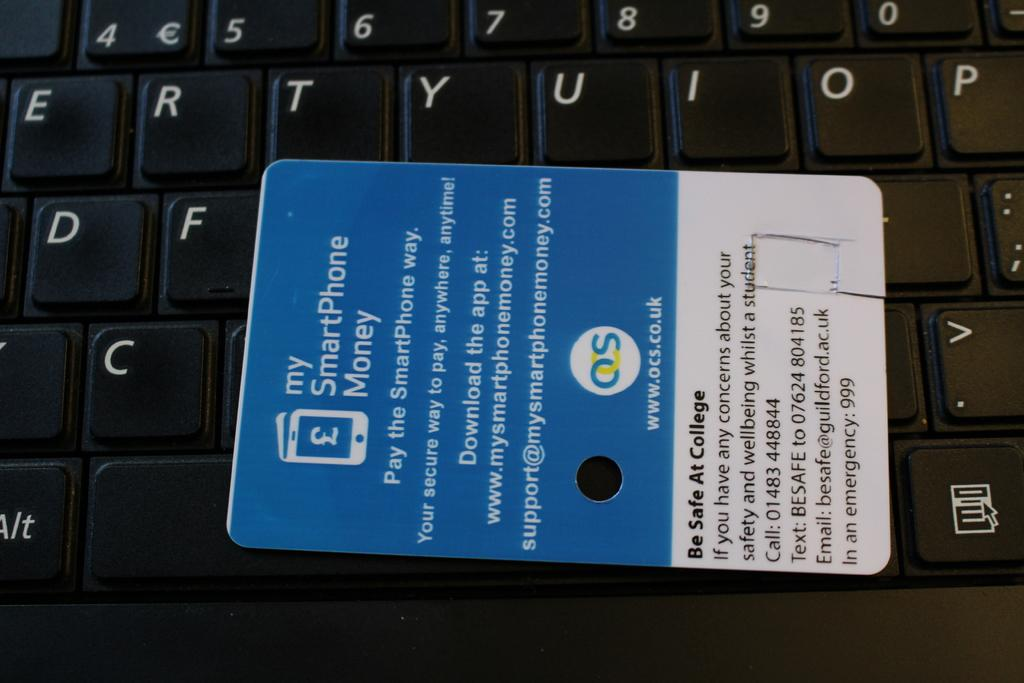Provide a one-sentence caption for the provided image. An advertising card for My SmartPhone Money, sponsored by OCS. 